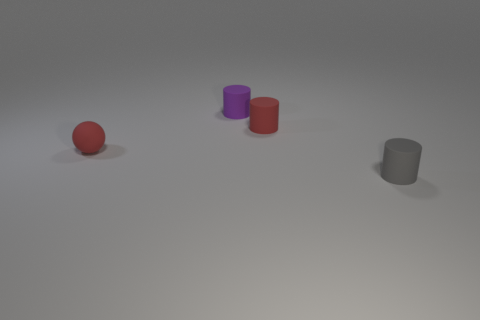Add 2 purple matte cylinders. How many objects exist? 6 Subtract all balls. How many objects are left? 3 Add 2 tiny red objects. How many tiny red objects exist? 4 Subtract 1 gray cylinders. How many objects are left? 3 Subtract all gray cylinders. Subtract all purple cylinders. How many objects are left? 2 Add 4 tiny purple rubber cylinders. How many tiny purple rubber cylinders are left? 5 